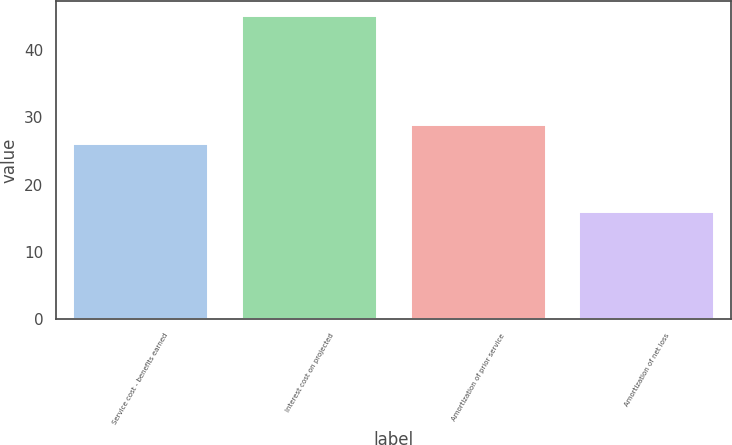<chart> <loc_0><loc_0><loc_500><loc_500><bar_chart><fcel>Service cost - benefits earned<fcel>Interest cost on projected<fcel>Amortization of prior service<fcel>Amortization of net loss<nl><fcel>26<fcel>45<fcel>28.9<fcel>16<nl></chart> 